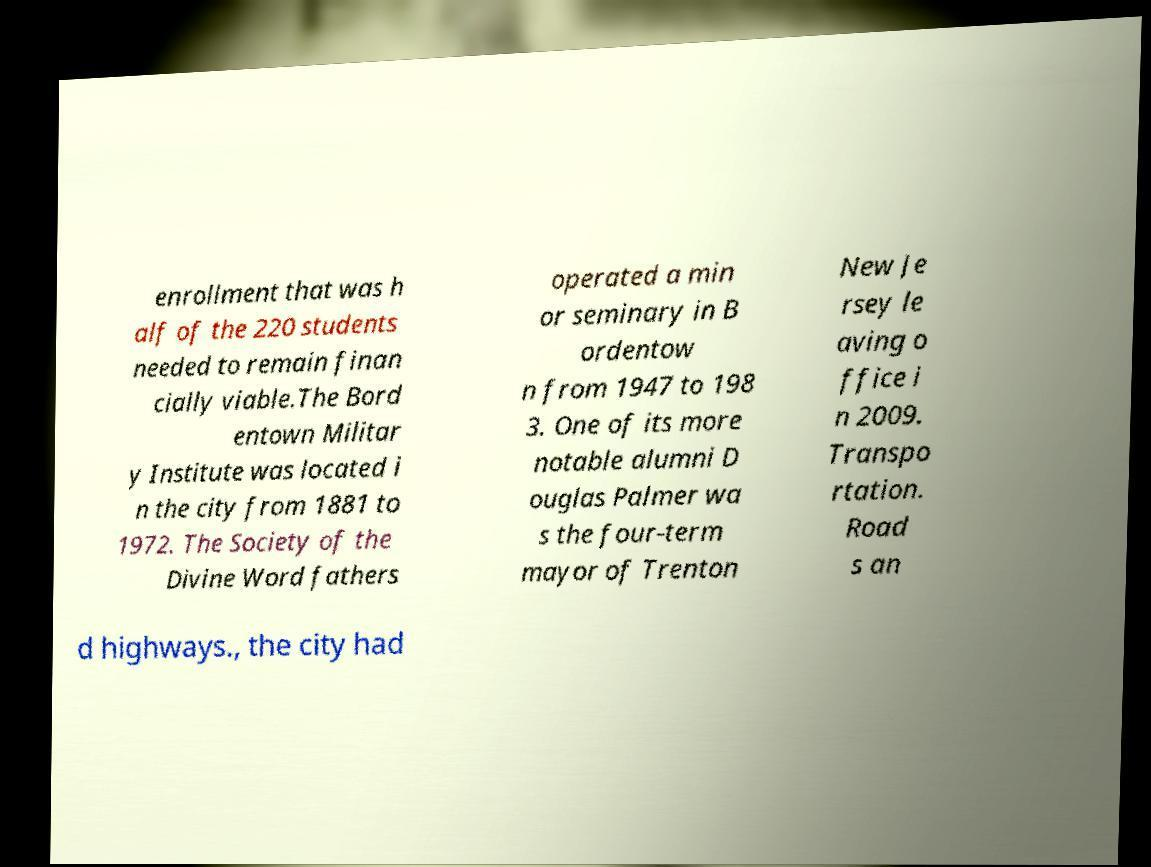Please read and relay the text visible in this image. What does it say? enrollment that was h alf of the 220 students needed to remain finan cially viable.The Bord entown Militar y Institute was located i n the city from 1881 to 1972. The Society of the Divine Word fathers operated a min or seminary in B ordentow n from 1947 to 198 3. One of its more notable alumni D ouglas Palmer wa s the four-term mayor of Trenton New Je rsey le aving o ffice i n 2009. Transpo rtation. Road s an d highways., the city had 